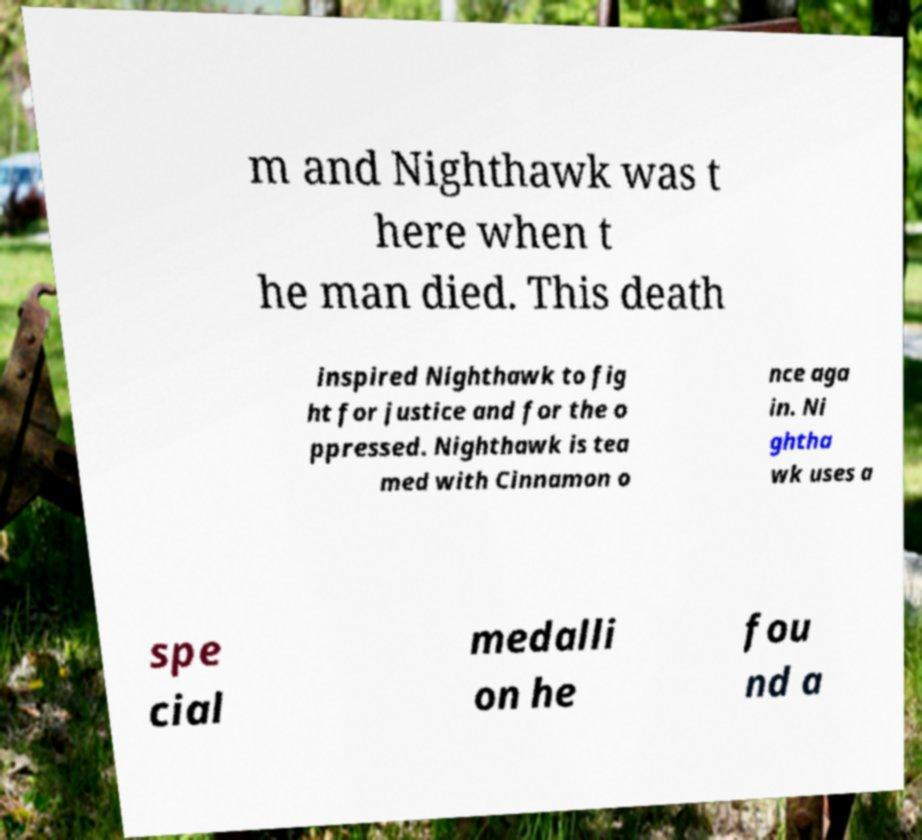Can you accurately transcribe the text from the provided image for me? m and Nighthawk was t here when t he man died. This death inspired Nighthawk to fig ht for justice and for the o ppressed. Nighthawk is tea med with Cinnamon o nce aga in. Ni ghtha wk uses a spe cial medalli on he fou nd a 